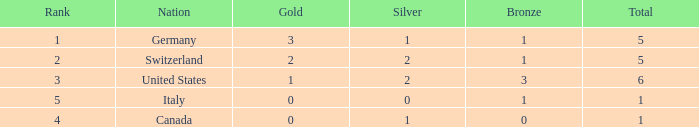How many golds for nations with over 0 silvers, over 1 total, and over 3 bronze? 0.0. 